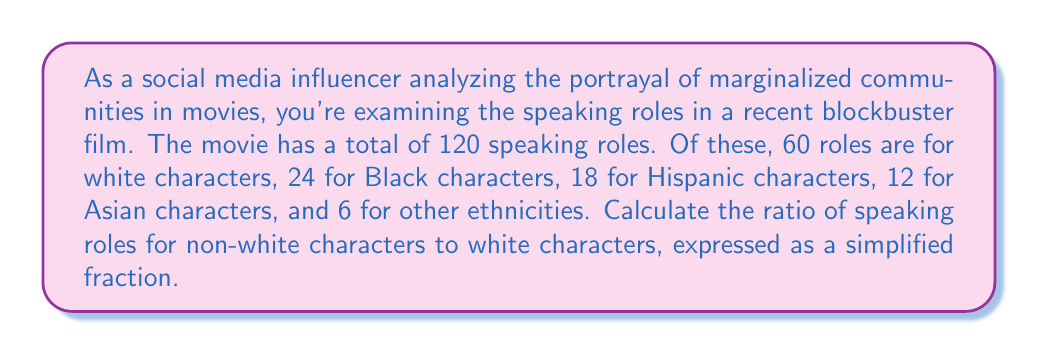Provide a solution to this math problem. To solve this problem, we need to follow these steps:

1. Calculate the total number of non-white speaking roles:
   Non-white roles = Black + Hispanic + Asian + Other
   $24 + 18 + 12 + 6 = 60$

2. Set up the ratio of non-white to white roles:
   $$\frac{\text{Non-white roles}}{\text{White roles}} = \frac{60}{60}$$

3. Simplify the fraction:
   $$\frac{60}{60} = \frac{1}{1}$$

This ratio indicates that for every 1 white speaking role, there is 1 non-white speaking role in the movie. 

It's worth noting that while this ratio shows an equal distribution between white and non-white roles overall, it doesn't reflect the diversity within the non-white category or how it compares to actual population demographics.
Answer: $\frac{1}{1}$ or 1:1 